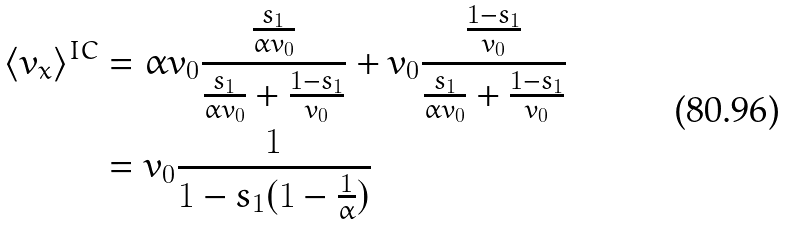<formula> <loc_0><loc_0><loc_500><loc_500>\langle v _ { x } \rangle ^ { I C } & = \alpha v _ { 0 } \frac { \frac { s _ { 1 } } { \alpha v _ { 0 } } } { \frac { s _ { 1 } } { \alpha v _ { 0 } } + \frac { 1 - s _ { 1 } } { v _ { 0 } } } + v _ { 0 } \frac { \frac { 1 - s _ { 1 } } { v _ { 0 } } } { \frac { s _ { 1 } } { \alpha v _ { 0 } } + \frac { 1 - s _ { 1 } } { v _ { 0 } } } \\ & = v _ { 0 } \frac { 1 } { 1 - s _ { 1 } ( 1 - \frac { 1 } { \alpha } ) }</formula> 